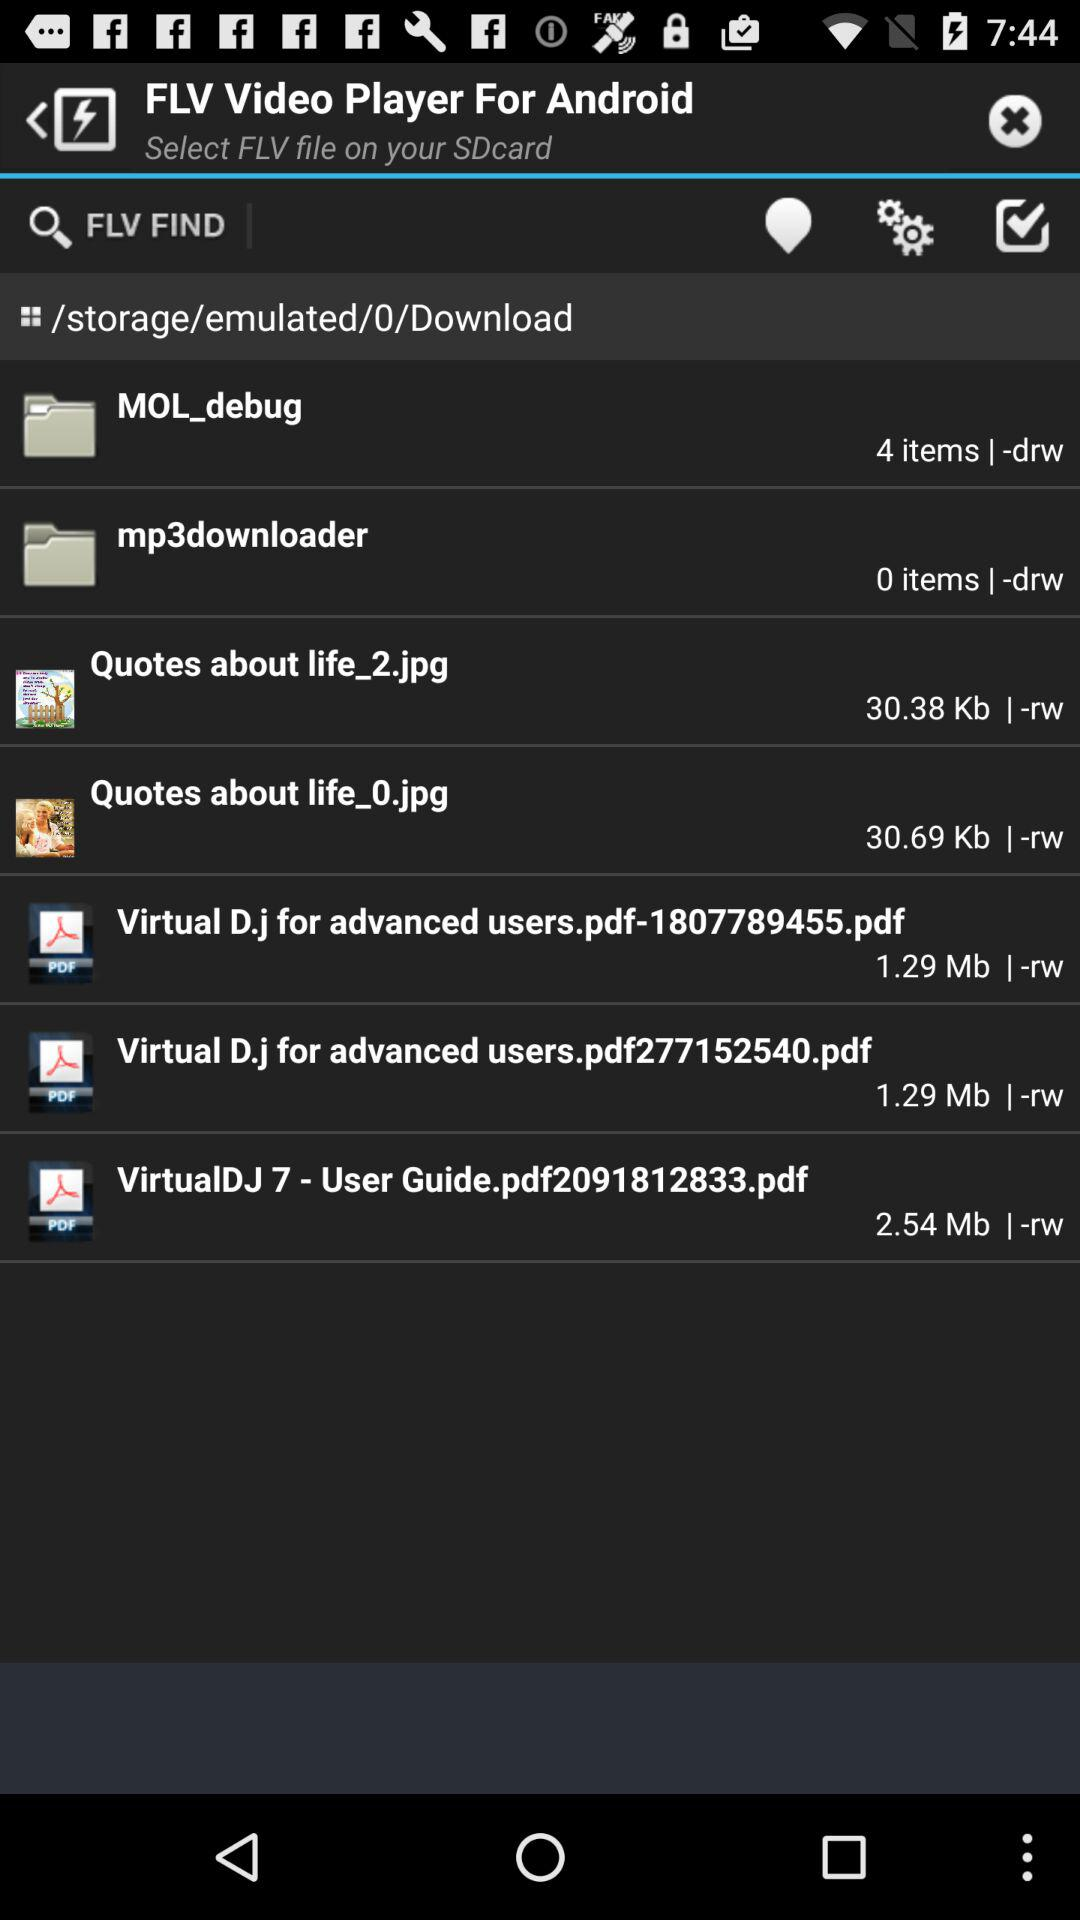How many items are there in "MOL_debug"? There are 4 items in "MOL_debug". 